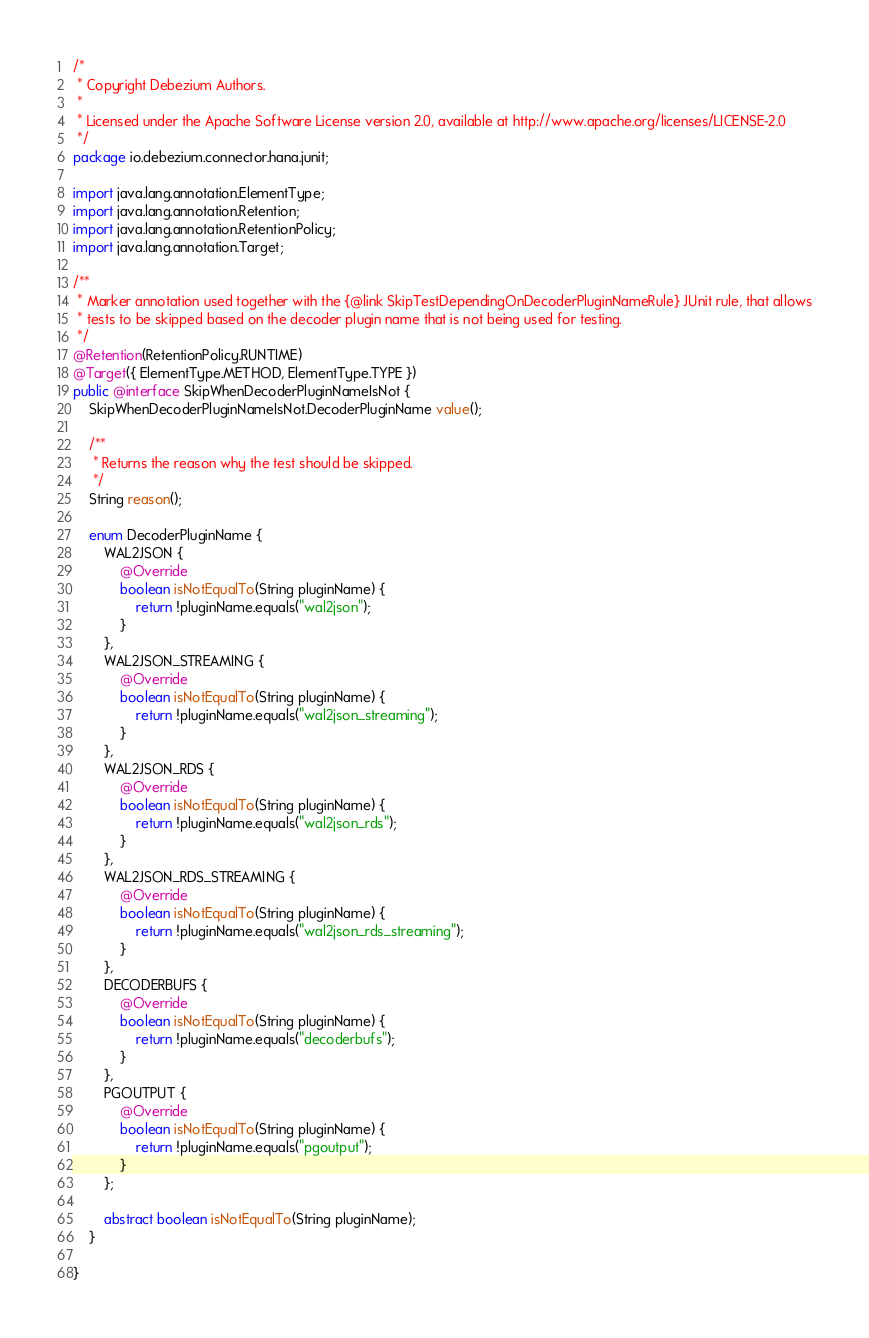Convert code to text. <code><loc_0><loc_0><loc_500><loc_500><_Java_>/*
 * Copyright Debezium Authors.
 *
 * Licensed under the Apache Software License version 2.0, available at http://www.apache.org/licenses/LICENSE-2.0
 */
package io.debezium.connector.hana.junit;

import java.lang.annotation.ElementType;
import java.lang.annotation.Retention;
import java.lang.annotation.RetentionPolicy;
import java.lang.annotation.Target;

/**
 * Marker annotation used together with the {@link SkipTestDependingOnDecoderPluginNameRule} JUnit rule, that allows
 * tests to be skipped based on the decoder plugin name that is not being used for testing.
 */
@Retention(RetentionPolicy.RUNTIME)
@Target({ ElementType.METHOD, ElementType.TYPE })
public @interface SkipWhenDecoderPluginNameIsNot {
    SkipWhenDecoderPluginNameIsNot.DecoderPluginName value();

    /**
     * Returns the reason why the test should be skipped.
     */
    String reason();

    enum DecoderPluginName {
        WAL2JSON {
            @Override
            boolean isNotEqualTo(String pluginName) {
                return !pluginName.equals("wal2json");
            }
        },
        WAL2JSON_STREAMING {
            @Override
            boolean isNotEqualTo(String pluginName) {
                return !pluginName.equals("wal2json_streaming");
            }
        },
        WAL2JSON_RDS {
            @Override
            boolean isNotEqualTo(String pluginName) {
                return !pluginName.equals("wal2json_rds");
            }
        },
        WAL2JSON_RDS_STREAMING {
            @Override
            boolean isNotEqualTo(String pluginName) {
                return !pluginName.equals("wal2json_rds_streaming");
            }
        },
        DECODERBUFS {
            @Override
            boolean isNotEqualTo(String pluginName) {
                return !pluginName.equals("decoderbufs");
            }
        },
        PGOUTPUT {
            @Override
            boolean isNotEqualTo(String pluginName) {
                return !pluginName.equals("pgoutput");
            }
        };

        abstract boolean isNotEqualTo(String pluginName);
    }

}
</code> 